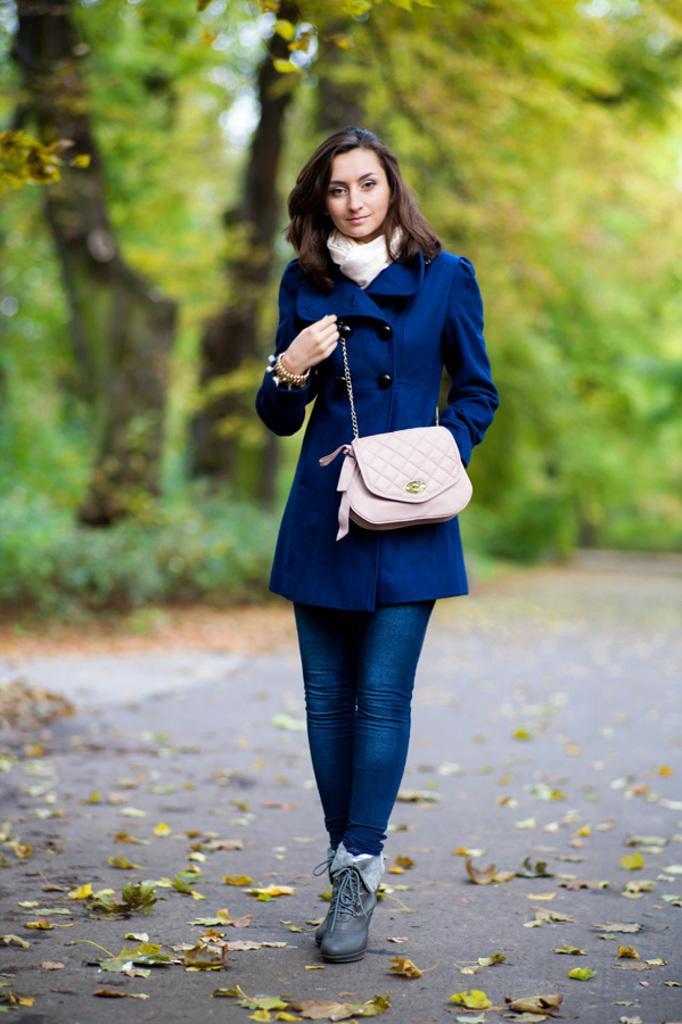Describe this image in one or two sentences. In the foreground a woman is walking on the road, who is wearing a blue color suit and light cream color bag in her hand and scarf of white in color. In the background trees are visible and sky visible. This image is taken on the road during day time. 